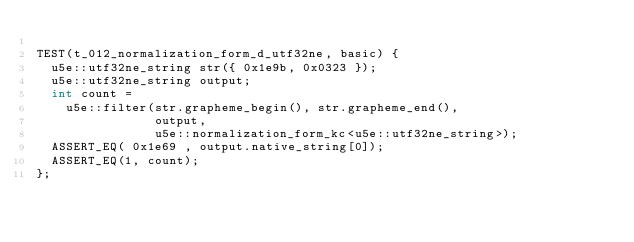<code> <loc_0><loc_0><loc_500><loc_500><_C++_>
TEST(t_012_normalization_form_d_utf32ne, basic) { 
  u5e::utf32ne_string str({ 0x1e9b, 0x0323 });
  u5e::utf32ne_string output;
  int count =
    u5e::filter(str.grapheme_begin(), str.grapheme_end(),
                output,
                u5e::normalization_form_kc<u5e::utf32ne_string>);
  ASSERT_EQ( 0x1e69 , output.native_string[0]);
  ASSERT_EQ(1, count);
};
</code> 